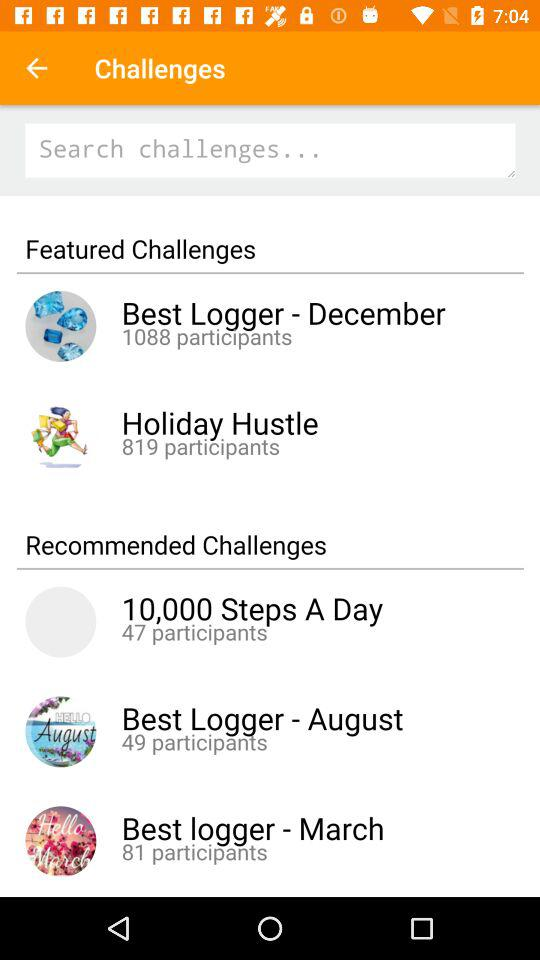How many participants are there in the Best Logger-December? There are 1088 participants in the Best Logger-December. 